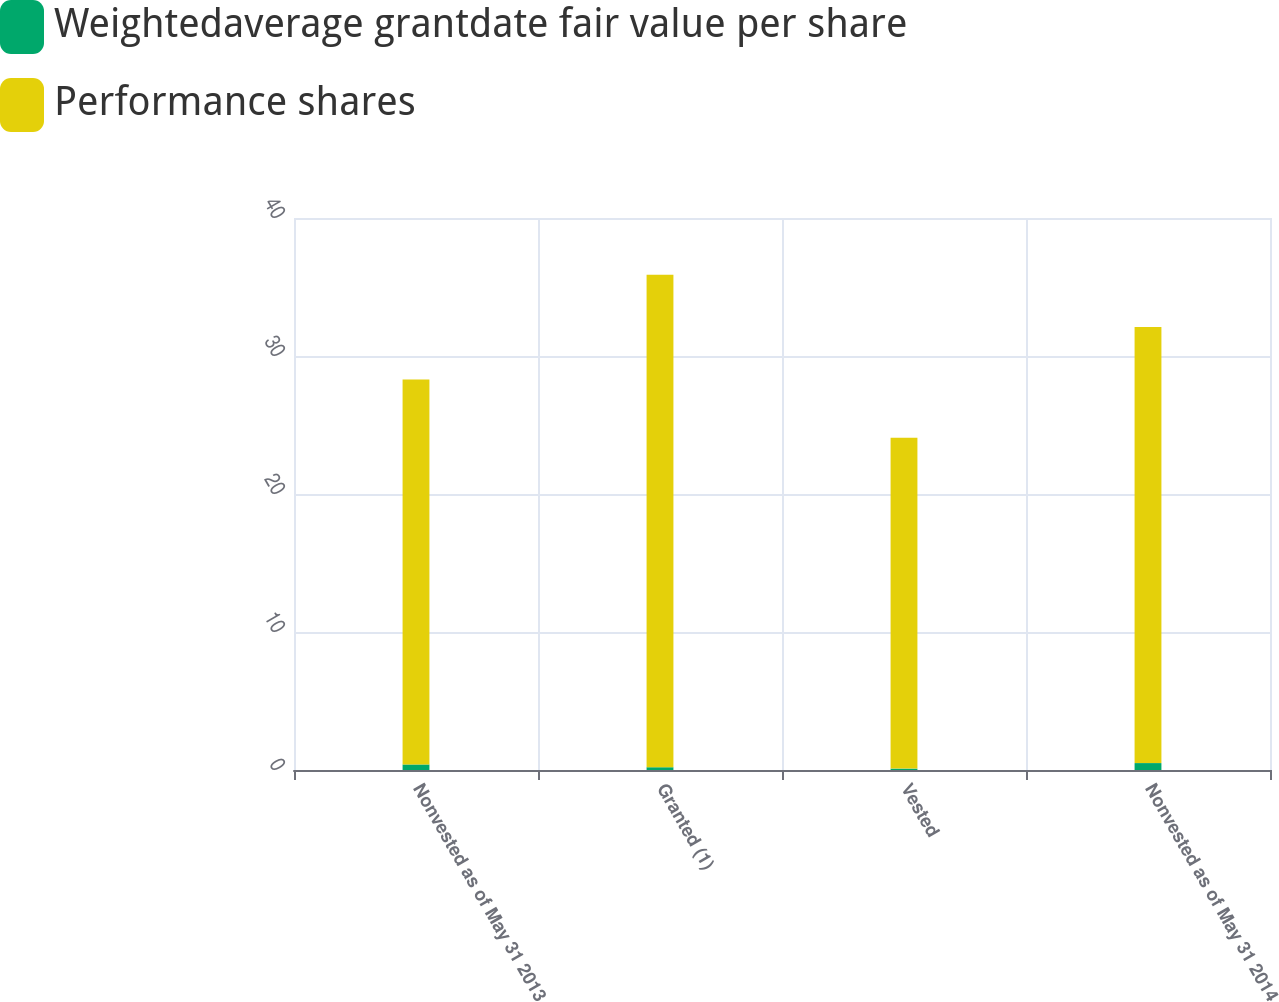Convert chart. <chart><loc_0><loc_0><loc_500><loc_500><stacked_bar_chart><ecel><fcel>Nonvested as of May 31 2013<fcel>Granted (1)<fcel>Vested<fcel>Nonvested as of May 31 2014<nl><fcel>Weightedaverage grantdate fair value per share<fcel>0.4<fcel>0.2<fcel>0.1<fcel>0.5<nl><fcel>Performance shares<fcel>27.89<fcel>35.69<fcel>23.98<fcel>31.61<nl></chart> 